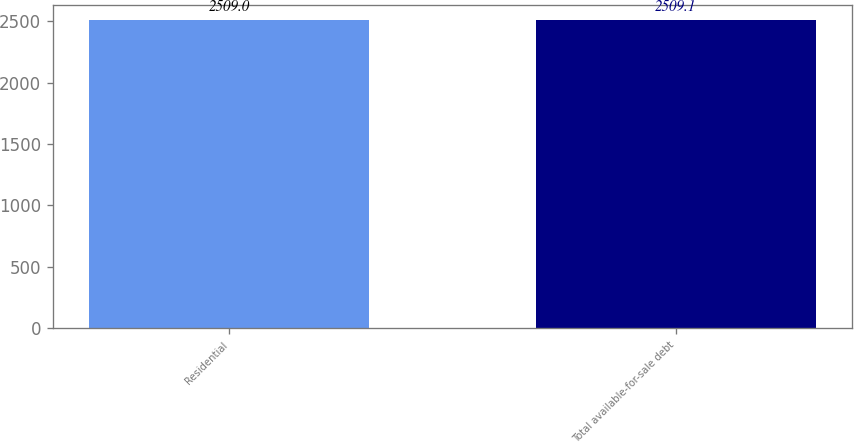Convert chart. <chart><loc_0><loc_0><loc_500><loc_500><bar_chart><fcel>Residential<fcel>Total available-for-sale debt<nl><fcel>2509<fcel>2509.1<nl></chart> 